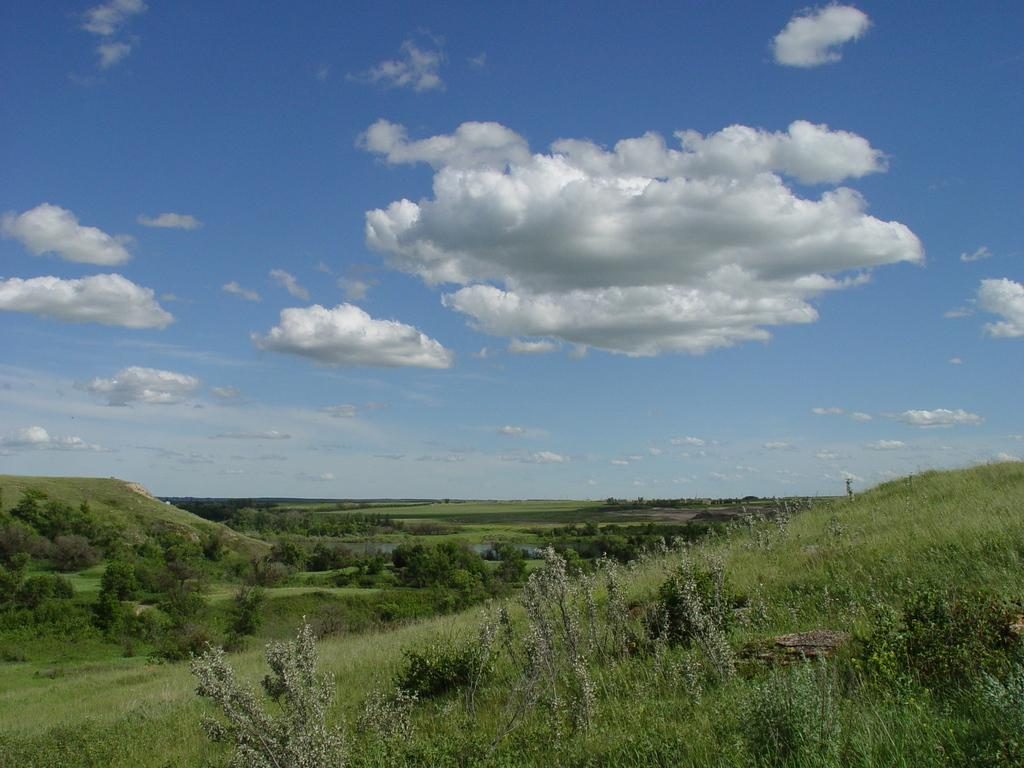What type of landscape is shown in the image? The image depicts an empty grassland. Are there any specific features within the grassland? Yes, there are trees in the grassland. How is the sky described in the image? The sky is visible in the image and is described as beautiful. What type of picture is included in the letter that is being delivered in the image? There is no letter or picture present in the image; it only shows an empty grassland with trees and a beautiful sky. 